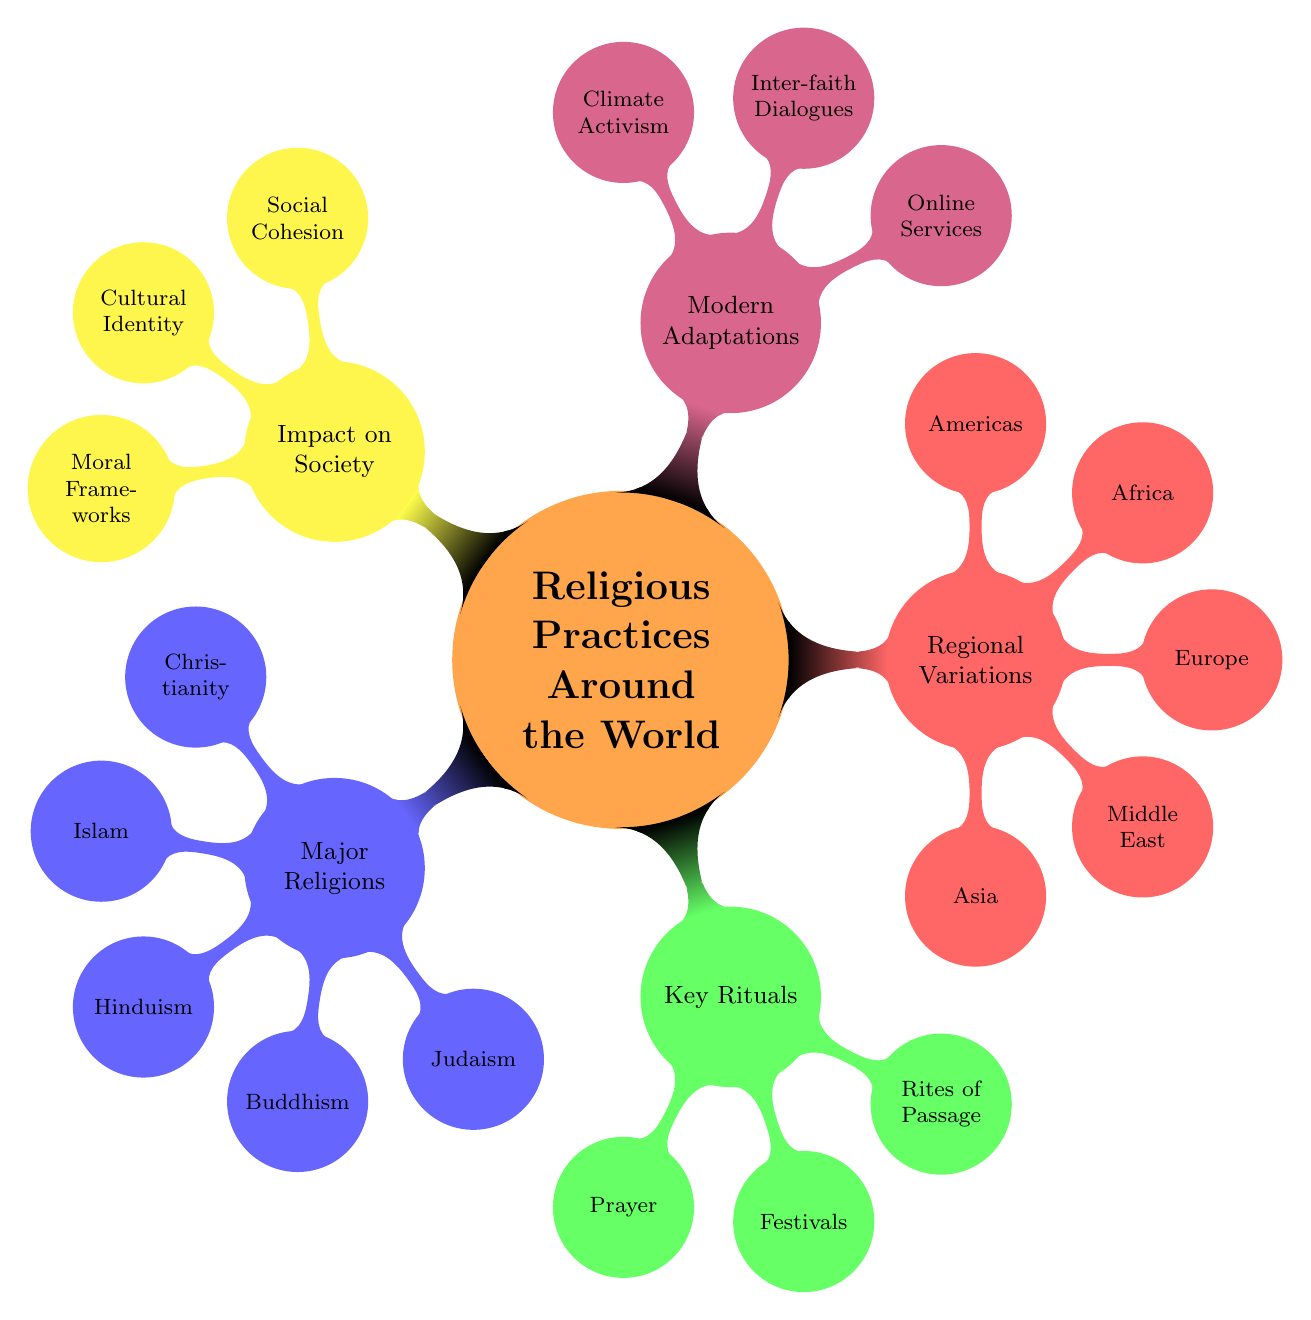What are the major religions listed in the diagram? The major religions can be found in the 'Major Religions' node. Under this node, the types of religions mentioned include Christianity, Islam, Hinduism, Buddhism, and Judaism.
Answer: Christianity, Islam, Hinduism, Buddhism, Judaism How many key rituals are mentioned in the diagram? To determine the number of key rituals, we look under the 'Key Rituals' node. The rituals listed here are Prayer, Festivals, and Rites of Passage, totaling three key rituals.
Answer: 3 Which region includes Hinduism in India? The node 'Hinduism in India' is located under the 'Regional Variations' node. Specifically, it is categorized under the sub-node 'Asia'.
Answer: Asia What is one modern adaptation mentioned in the diagram? The 'Modern Adaptations' node has the following adaptations listed: Online Services, Inter-faith Dialogues, and Climate Activism. Any of these adaptations can be mentioned as a modern adaptation.
Answer: Online Services How does 'Social Cohesion' fit into the impact on society? 'Social Cohesion' is found under the 'Impact on Society' node. It represents one of the key influences that religious practices have on communities and relationships among individuals in society.
Answer: Social Cohesion Which key ritual involves a holiday celebration? Among the key rituals listed under the 'Key Rituals' node, Festivals is the category that includes holiday celebrations like Easter, Ramadan, and Diwali.
Answer: Festivals How many regions are displayed in the regional variations? Under the 'Regional Variations' node, the regions mentioned include Asia, Middle East, Europe, Africa, and Americas. Counting these, there are five regions shown.
Answer: 5 What relationship exists between 'Judaism' and 'Prayer'? 'Judaism' is one of the major religions listed under the 'Major Religions' node, and it has a specific key ritual associated with it called 'Jewish Tefillah' under the 'Prayer' category in 'Key Rituals'. This indicates that Jewish prayer practices are integral to Judaism.
Answer: Jewish Tefillah Which impact is associated with 'Moral Frameworks'? 'Moral Frameworks' is found as one of the sub-nodes under the 'Impact on Society' category. It signifies how religious practices influence ethical standards and morality in various societies.
Answer: Moral Frameworks 